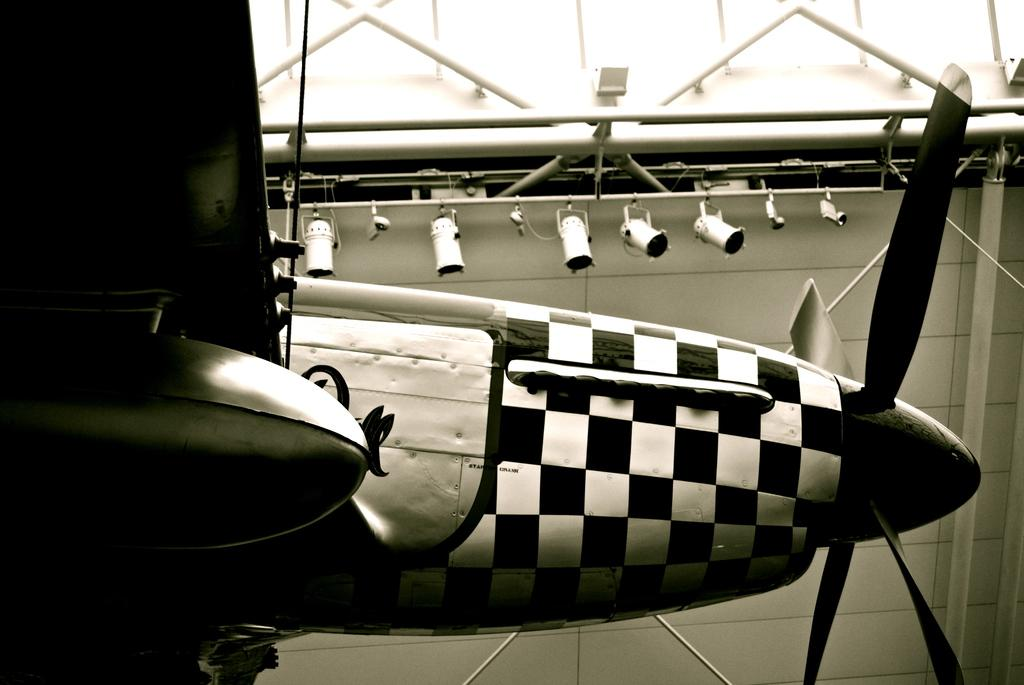What is the main subject of the image? The main subject of the image is a flying jet. What other objects can be seen in the image? There are iron poles and lights visible in the image. What news is being reported by the army in the image? There is no news or army present in the image; it features a flying jet, iron poles, and lights. 